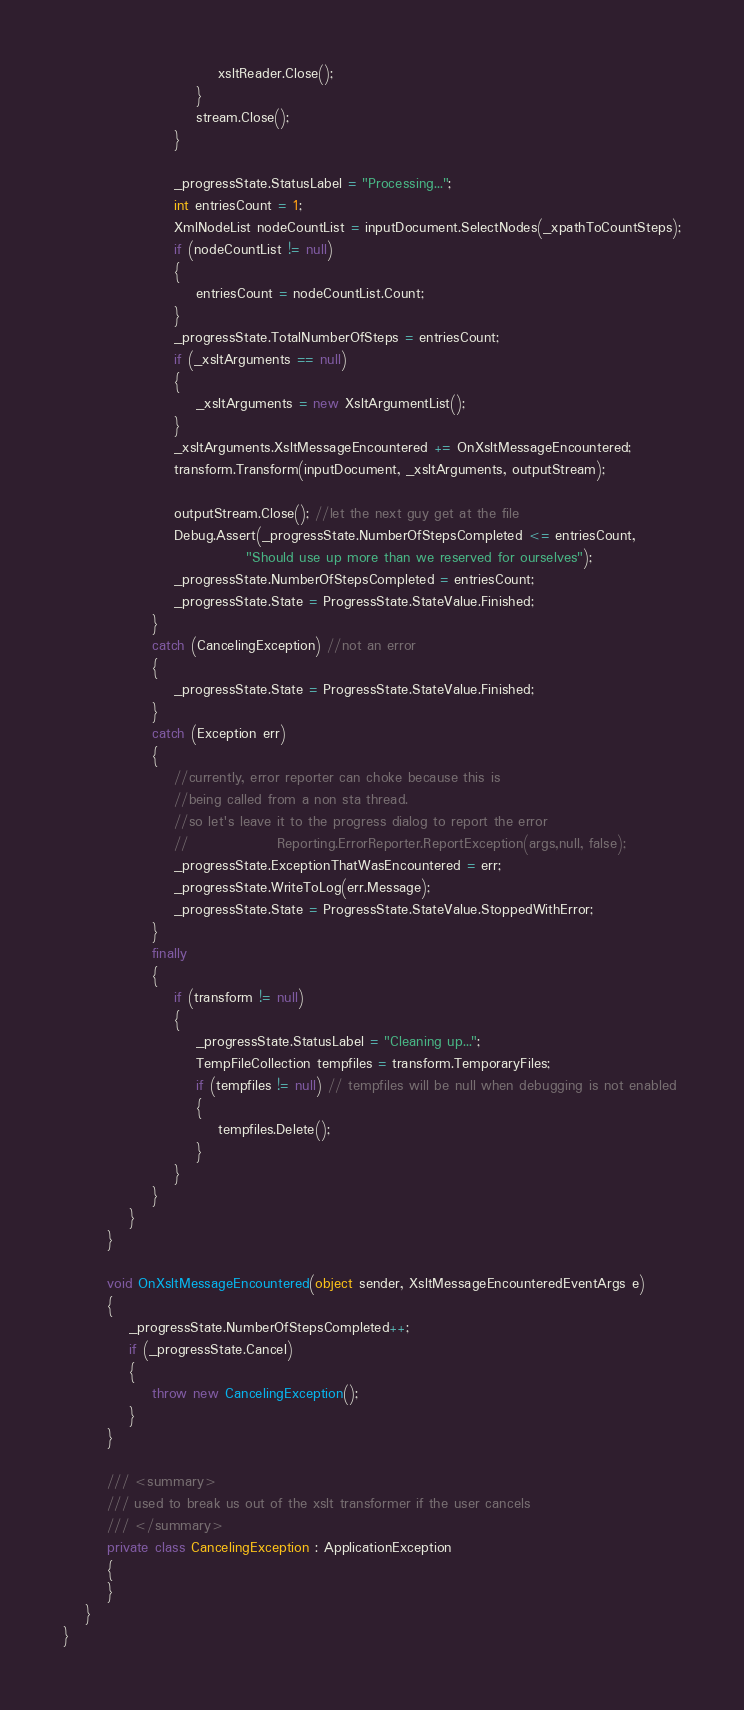Convert code to text. <code><loc_0><loc_0><loc_500><loc_500><_C#_>							xsltReader.Close();
						}
						stream.Close();
					}

					_progressState.StatusLabel = "Processing...";
					int entriesCount = 1;
					XmlNodeList nodeCountList = inputDocument.SelectNodes(_xpathToCountSteps);
					if (nodeCountList != null)
					{
						entriesCount = nodeCountList.Count;
					}
					_progressState.TotalNumberOfSteps = entriesCount;
					if (_xsltArguments == null)
					{
						_xsltArguments = new XsltArgumentList();
					}
					_xsltArguments.XsltMessageEncountered += OnXsltMessageEncountered;
					transform.Transform(inputDocument, _xsltArguments, outputStream);

					outputStream.Close(); //let the next guy get at the file
					Debug.Assert(_progressState.NumberOfStepsCompleted <= entriesCount,
								 "Should use up more than we reserved for ourselves");
					_progressState.NumberOfStepsCompleted = entriesCount;
					_progressState.State = ProgressState.StateValue.Finished;
				}
				catch (CancelingException) //not an error
				{
					_progressState.State = ProgressState.StateValue.Finished;
				}
				catch (Exception err)
				{
					//currently, error reporter can choke because this is
					//being called from a non sta thread.
					//so let's leave it to the progress dialog to report the error
					//                Reporting.ErrorReporter.ReportException(args,null, false);
					_progressState.ExceptionThatWasEncountered = err;
					_progressState.WriteToLog(err.Message);
					_progressState.State = ProgressState.StateValue.StoppedWithError;
				}
				finally
				{
					if (transform != null)
					{
						_progressState.StatusLabel = "Cleaning up...";
						TempFileCollection tempfiles = transform.TemporaryFiles;
						if (tempfiles != null) // tempfiles will be null when debugging is not enabled
						{
							tempfiles.Delete();
						}
					}
				}
			}
		}

		void OnXsltMessageEncountered(object sender, XsltMessageEncounteredEventArgs e)
		{
			_progressState.NumberOfStepsCompleted++;
			if (_progressState.Cancel)
			{
				throw new CancelingException();
			}
		}

		/// <summary>
		/// used to break us out of the xslt transformer if the user cancels
		/// </summary>
		private class CancelingException : ApplicationException
		{
		}
	}
}</code> 